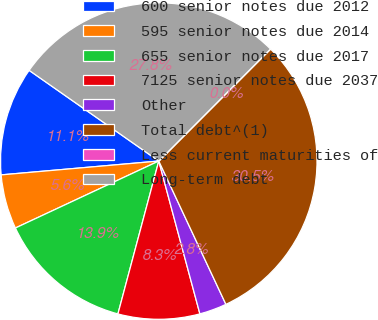Convert chart. <chart><loc_0><loc_0><loc_500><loc_500><pie_chart><fcel>600 senior notes due 2012<fcel>595 senior notes due 2014<fcel>655 senior notes due 2017<fcel>7125 senior notes due 2037<fcel>Other<fcel>Total debt^(1)<fcel>Less current maturities of<fcel>Long-term debt<nl><fcel>11.11%<fcel>5.56%<fcel>13.89%<fcel>8.34%<fcel>2.79%<fcel>30.54%<fcel>0.01%<fcel>27.76%<nl></chart> 